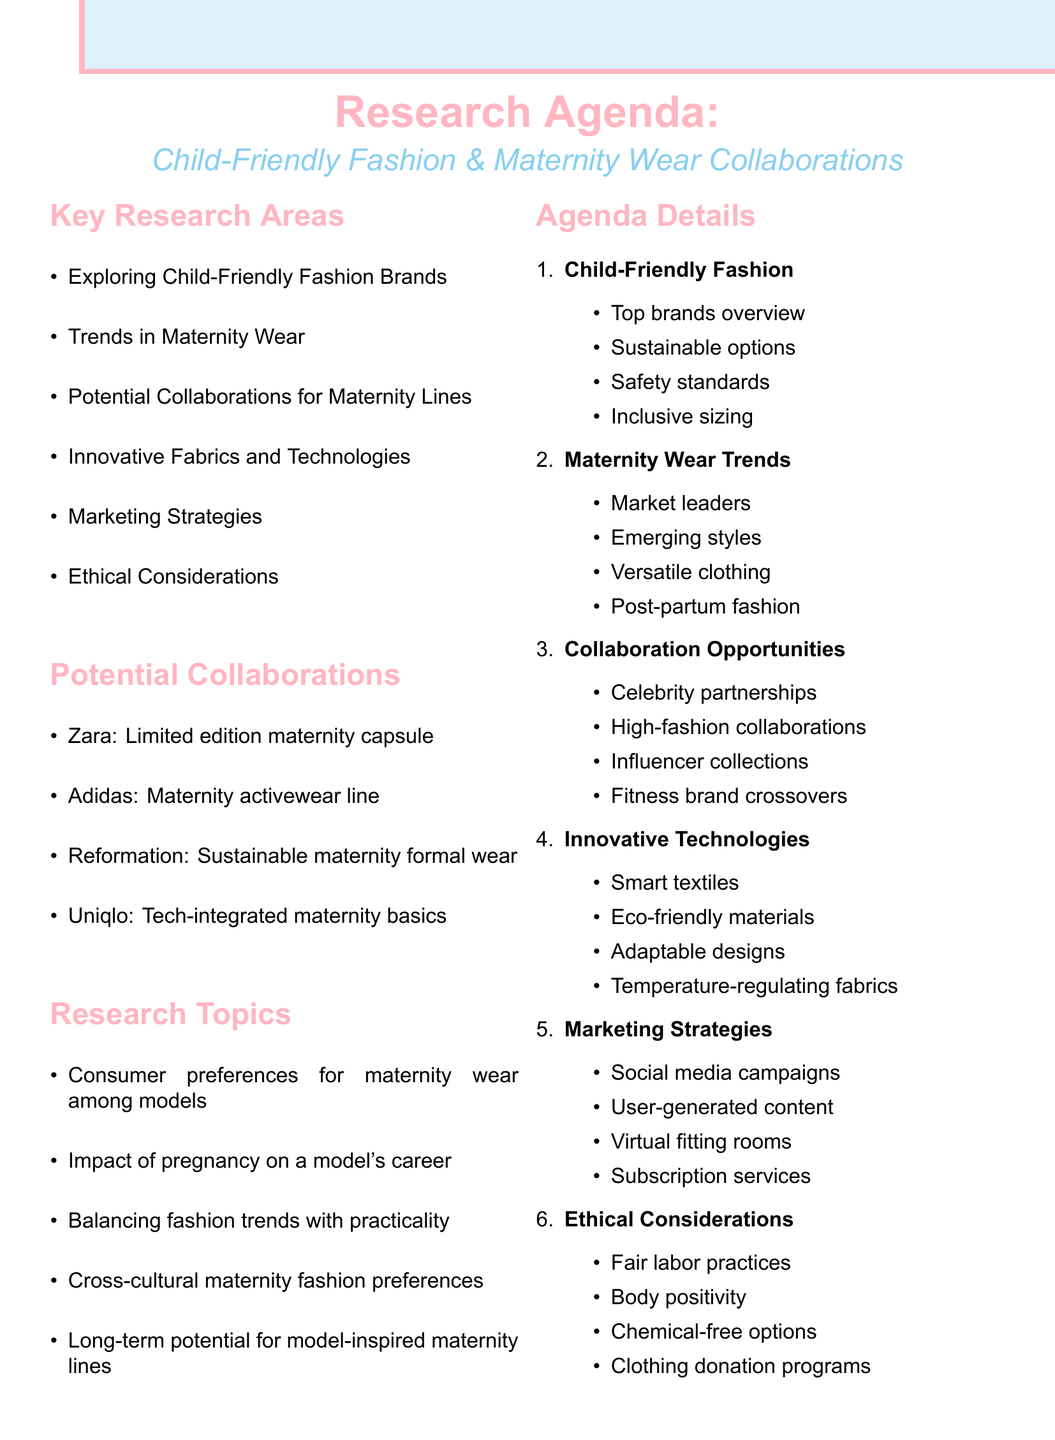What are the potential collaborations mentioned for maternity wear? The document lists potential collaborations under a specific section, including Zara, Adidas, Reformation, and Uniqlo.
Answer: Zara, Adidas, Reformation, Uniqlo What is one of the subtopics discussed under "Trends in Maternity Wear"? The document provides various subtopics related to maternity wear trends, including current market leaders, emerging styles, versatile clothing, and post-partum fashion.
Answer: Current market leaders What is the target audience for the Reformation project? The document specifies the target audience for each collaboration project, indicating eco-conscious pregnant brides and event-goers for Reformation.
Answer: Eco-conscious pregnant brides and event-goers Which area or topic focuses on safety and inclusive sizing? The agenda item explores different child-friendly fashion brands, discussing children's clothing options related to safety and inclusivity.
Answer: Exploring Child-Friendly Fashion Brands What is a research topic related to models? The document lists research topics, including "Impact of pregnancy on a model's career and brand partnerships."
Answer: Impact of pregnancy on a model's career Which brand is associated with a limited edition maternity capsule collection? The document explicitly states that Zara is associated with this specific collaboration project.
Answer: Zara How many key research areas are listed in the document? The document outlines key research areas, which are mentioned in a concise list format.
Answer: Six What is one of the innovative technologies mentioned for maternity wear? The document includes a section on innovative fabrics and technologies, mentioning smart textiles as one of the examples.
Answer: Smart textiles 